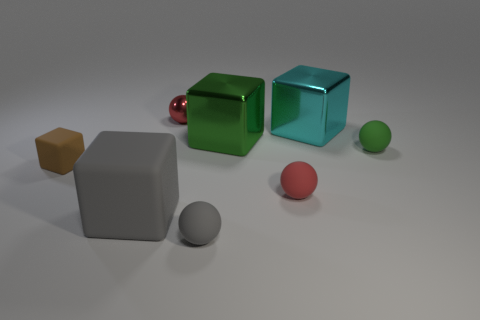What material is the tiny green object that is the same shape as the tiny red matte thing?
Your response must be concise. Rubber. What number of green objects are there?
Offer a terse response. 2. What shape is the gray matte object that is to the left of the gray sphere?
Offer a very short reply. Cube. What is the color of the metal thing on the right side of the big shiny block in front of the cyan metallic cube in front of the tiny metallic object?
Give a very brief answer. Cyan. The big object that is made of the same material as the small green object is what shape?
Your answer should be compact. Cube. Are there fewer big cyan cubes than big yellow metallic things?
Make the answer very short. No. Is the small green sphere made of the same material as the gray sphere?
Offer a very short reply. Yes. How many other objects are there of the same color as the small matte block?
Your response must be concise. 0. Are there more small purple metal spheres than metallic objects?
Your answer should be compact. No. There is a metal sphere; is its size the same as the gray sphere in front of the red shiny object?
Make the answer very short. Yes. 